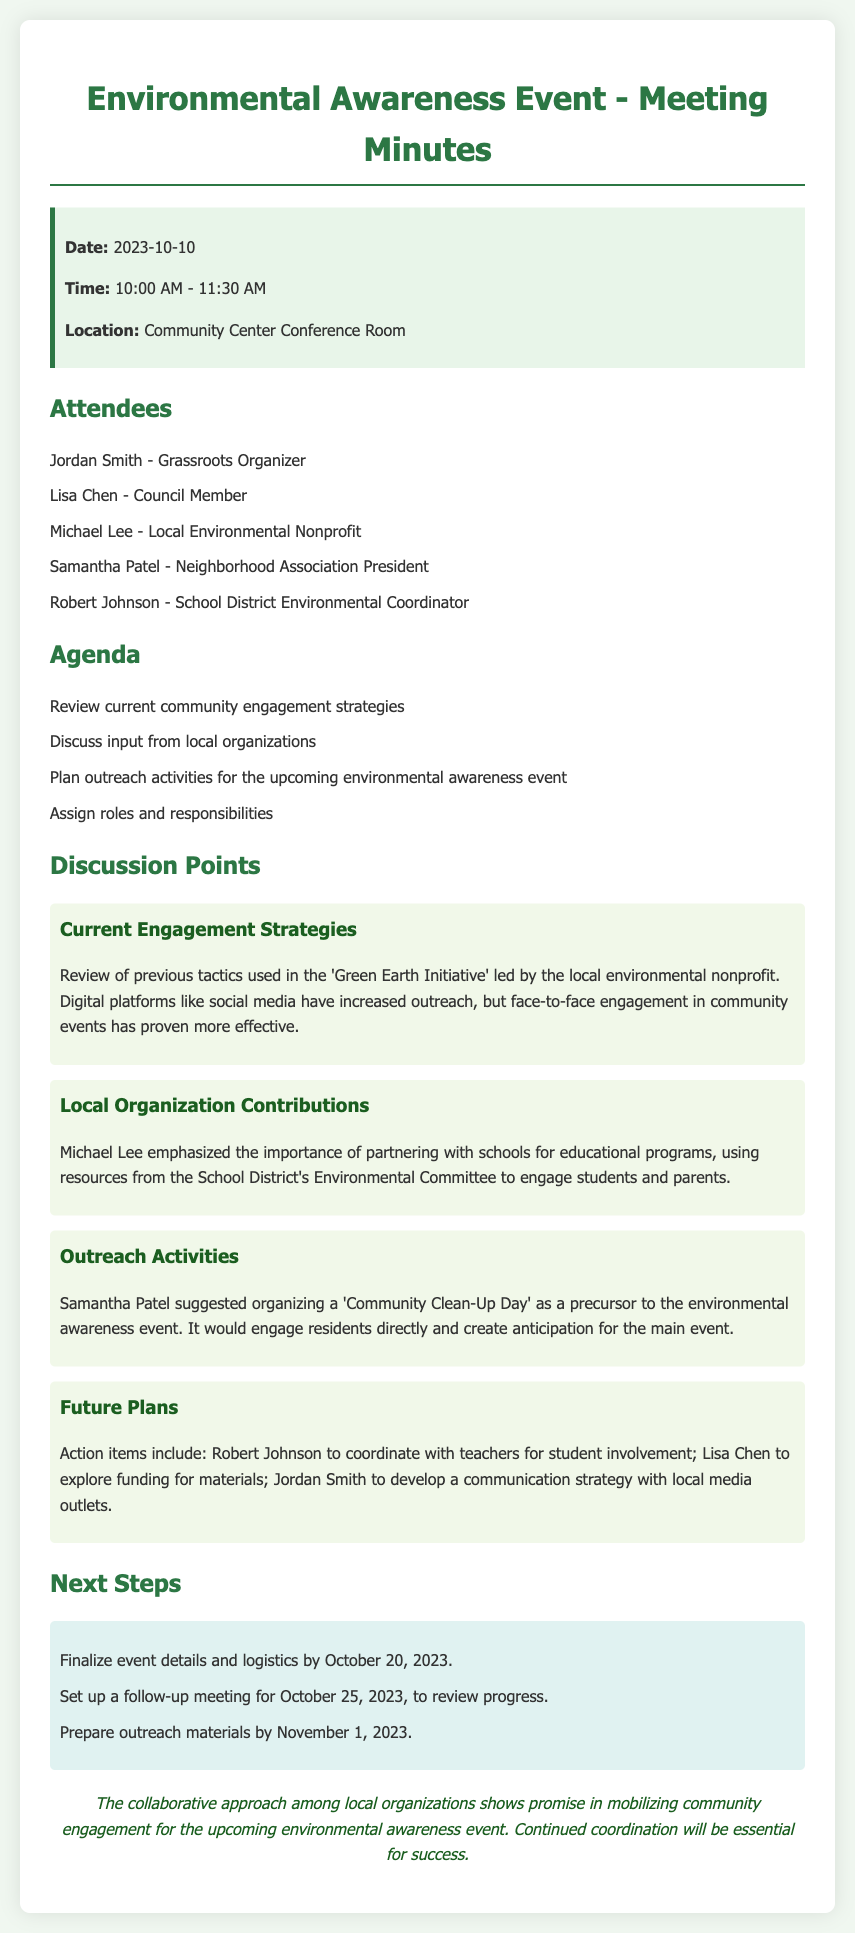what date was the meeting held? The date of the meeting is explicitly mentioned in the info box at the beginning of the document.
Answer: 2023-10-10 who emphasized the importance of partnering with schools? This information can be found in the discussion points section, specifically in the contribution from Michael Lee.
Answer: Michael Lee what is one outreach activity suggested for community engagement? The document mentions a suggestion made by Samantha Patel regarding an outreach activity.
Answer: Community Clean-Up Day when is the follow-up meeting scheduled? The follow-up meeting date is clearly outlined in the next steps section of the minutes.
Answer: October 25, 2023 who is responsible for developing a communication strategy? The action items list in the future plans section assigns this task to a specific individual.
Answer: Jordan Smith what is the location of the meeting? The location is provided in the info box at the beginning of the document.
Answer: Community Center Conference Room what is the deadline for preparing outreach materials? The next steps section includes a specific deadline for this activity.
Answer: November 1, 2023 which organization is Michael Lee associated with? The document identifies his role and organization in the attendees section.
Answer: Local Environmental Nonprofit 